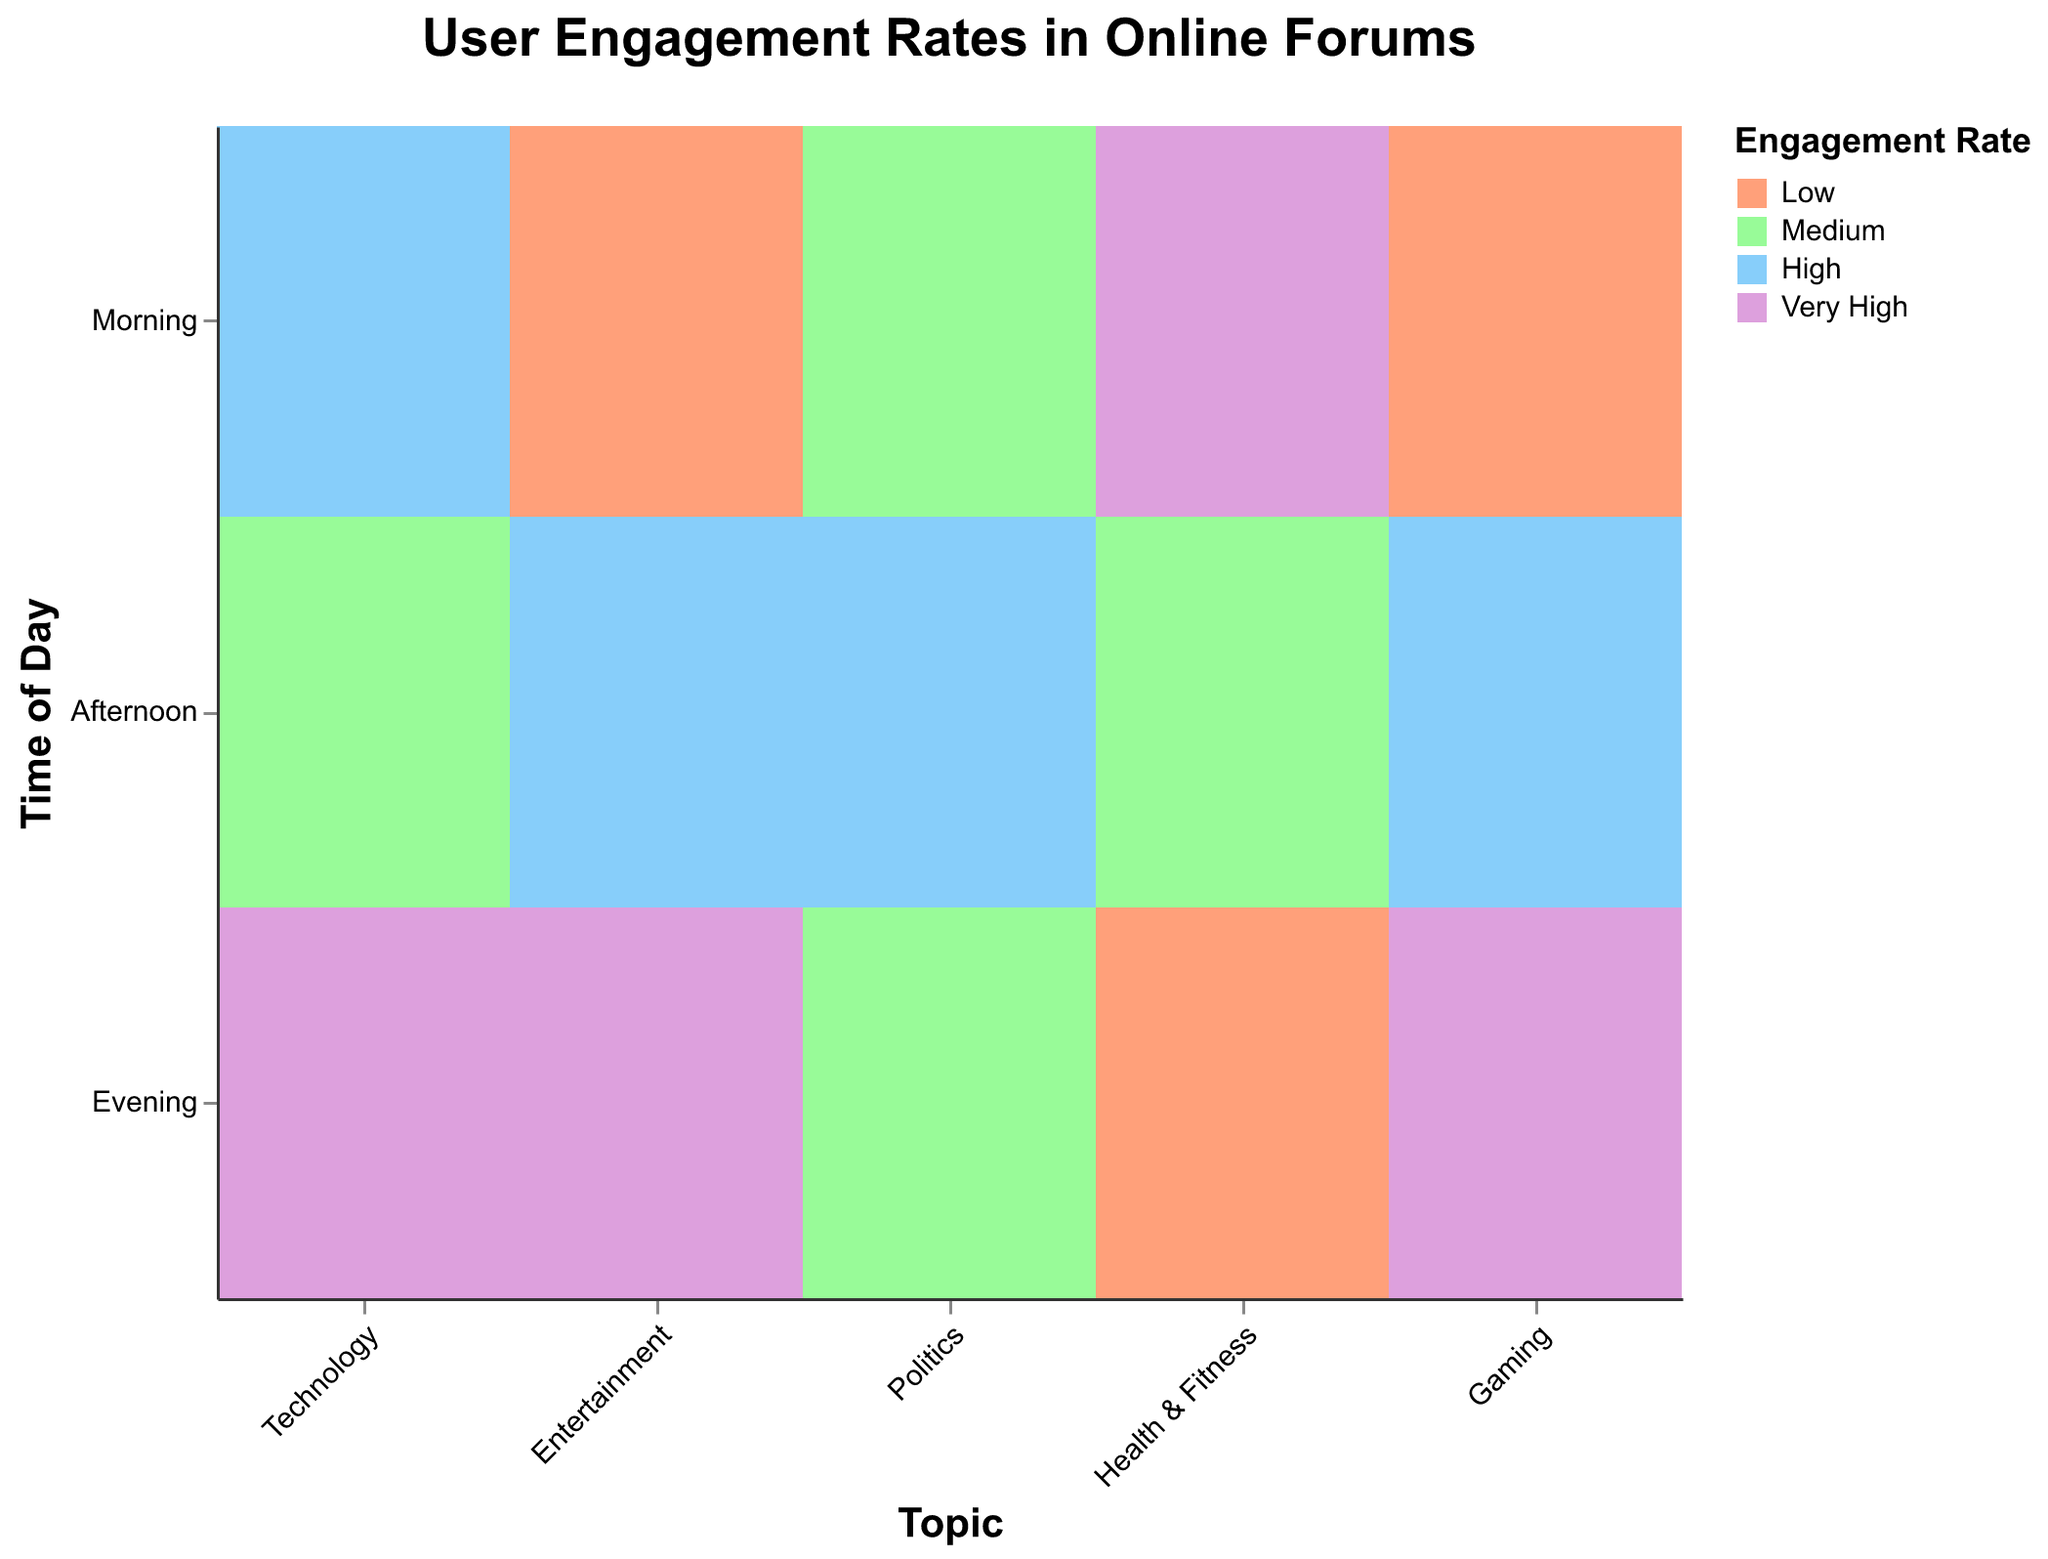What is the title of the figure? The title is usually found at the top of the figure and reads "User Engagement Rates in Online Forums".
Answer: User Engagement Rates in Online Forums How many different topics are represented in the figure? Look at the x-axis, which categorizes data by topics, there are five different topics represented: "Technology", "Entertainment", "Politics", "Health & Fitness", and "Gaming".
Answer: 5 During which time of day does the 'Health & Fitness' topic have the highest engagement rate? By looking at the 'Health & Fitness' category, check the color coding for the 'Engagement Rate'. 'Very High' (indicating the highest rate) is seen in the 'Morning' slot.
Answer: Morning Which topic features a low engagement rate in the evening? Look at the color-coded 'Low' engagement rate and the 'Evening' time of day. The 'Health & Fitness' topic shows 'Low' engagement in the evening.
Answer: Health & Fitness What is the user count for 'Technology' in the afternoon? Locate the 'Technology' category and then check the afternoon slot for the user count which is given directly.
Answer: 800 Among all topics, which has the highest user count in the evening? Compare the user count in the evening across all topics. The 'Gaming' topic shows the highest count of 2500 users.
Answer: Gaming What is the total user count in the morning across all topics? Sum the user counts for all topics during the morning: 1200 (Technology) + 300 (Entertainment) + 600 (Politics) + 1800 (Health & Fitness) + 250 (Gaming) = 4150.
Answer: 4150 Which topic experiences a 'High' engagement rate in both afternoon and evening? First, identify topics with a 'High' rate for the afternoon and then check which of the same topics also contain 'High' rate in the evening. None of the topics meet this criterion, so look for the highest available rate secondarily in the evening, ensuring no overlap is found.
Answer: None Is the user count higher in the morning or the afternoon for the 'Politics' topic? Look at the counts for 'Politics' in both time slots: 600 (morning) and 1100 (afternoon). Compare these two values and see that the afternoon has a higher count.
Answer: Afternoon Which topic and time have the lowest engagement rate combined with a user count higher than 1000? Identify 'Low' engagement rates across topics and check if any corresponding user counts exceed 1000. None meet this criterion, so restrict to lowest available meeting 1000 threshold. Check 'Medium' or 'High' as secondary and ensure result is valid.
Answer: None 